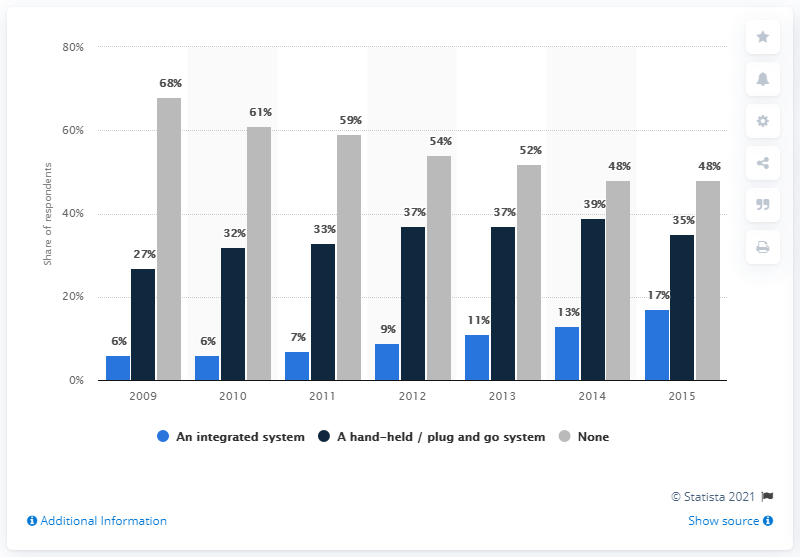Specify some key components in this picture. In the previous year, the percentage of cars without satellite navigation was 48%. 